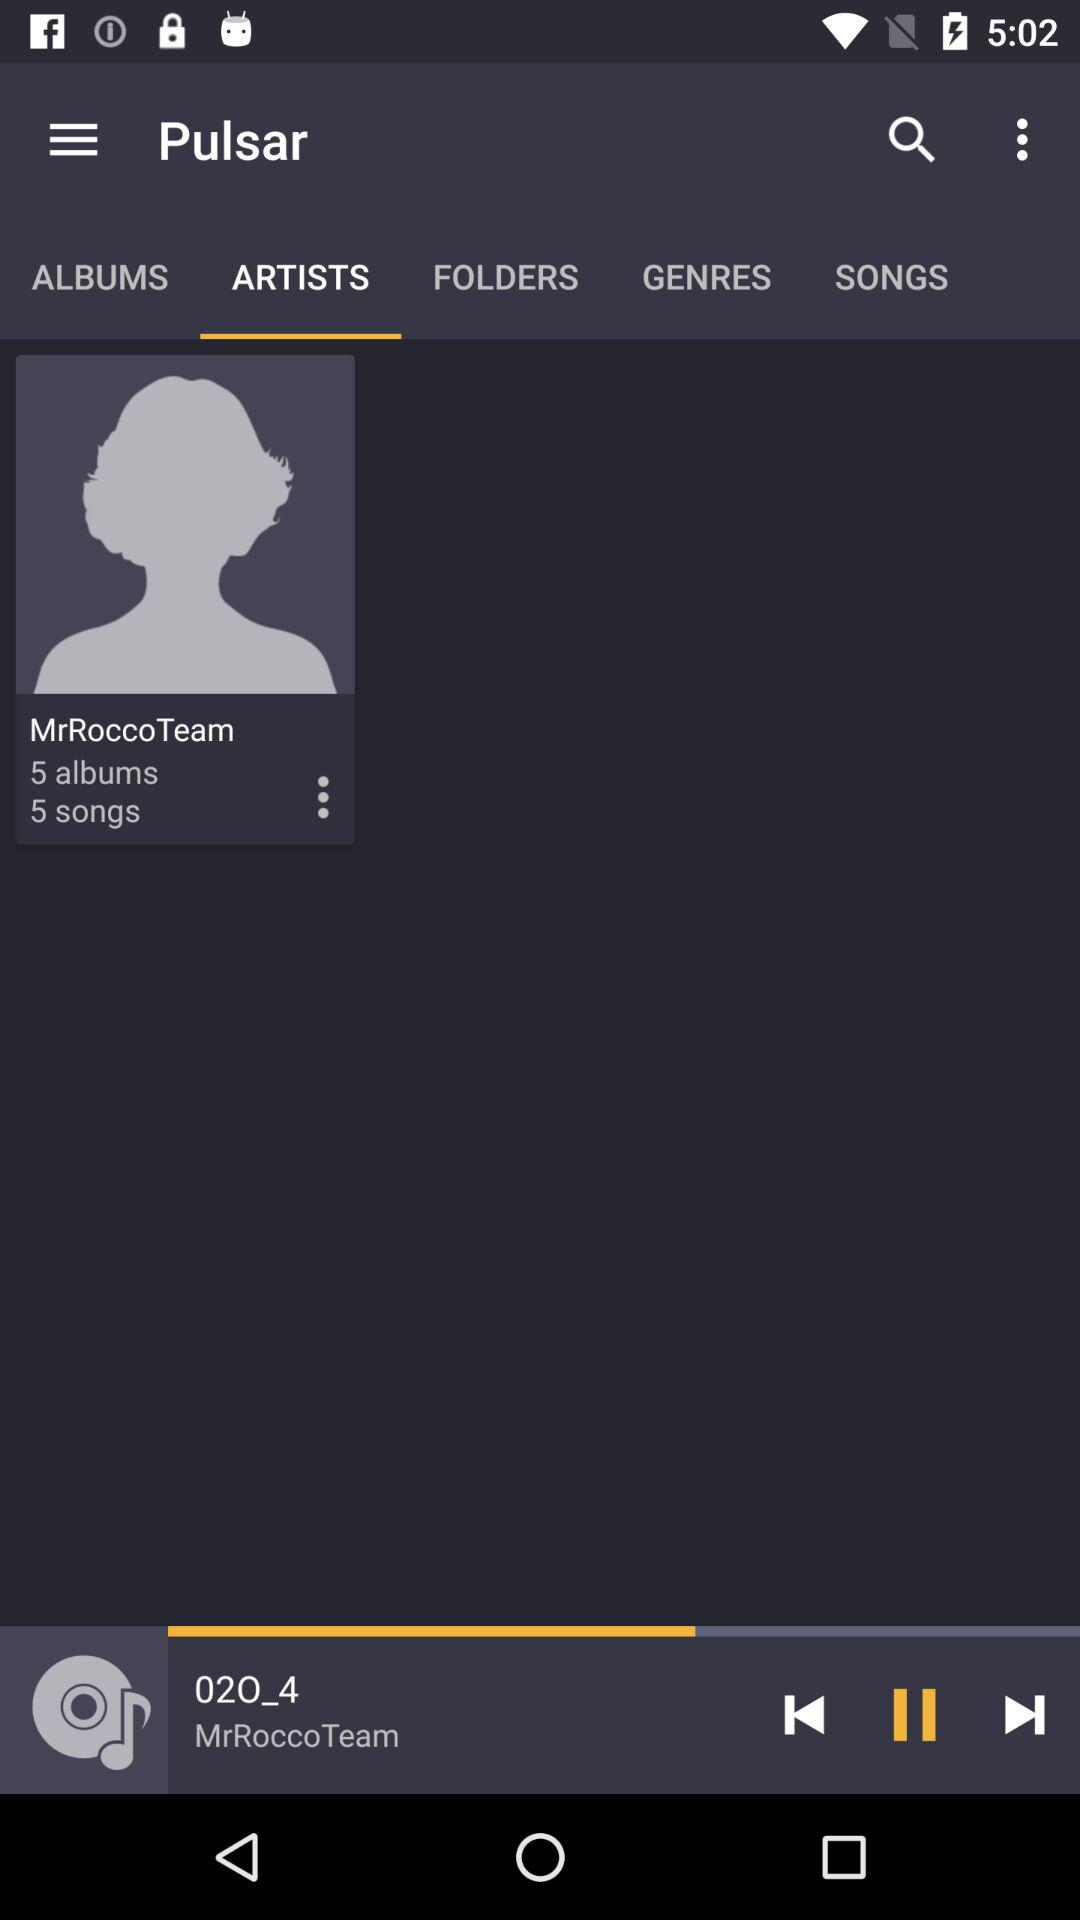Which option is selected for "Pulsar"? The selected option is "ARTISTS". 